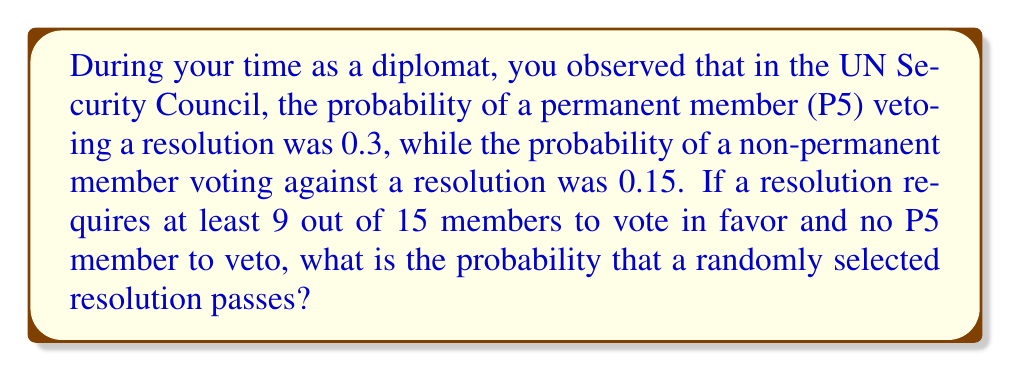Show me your answer to this math problem. Let's approach this step-by-step:

1) First, we need to calculate the probability that no P5 member vetoes the resolution:
   $P(\text{no veto}) = (1-0.3)^5 = 0.7^5 \approx 0.16807$

2) Now, we need to calculate the probability of at least 9 out of 15 members voting in favor. This is equivalent to the probability of 0 to 6 members voting against.

3) We can use the binomial probability formula:
   $P(X=k) = \binom{n}{k} p^k (1-p)^{n-k}$
   where $n=15$, $p=0.15$, and $k=0$ to $6$

4) Let's calculate this for each $k$ from 0 to 6:
   $P(X=0) = \binom{15}{0} 0.15^0 0.85^{15} \approx 0.0874$
   $P(X=1) = \binom{15}{1} 0.15^1 0.85^{14} \approx 0.2312$
   $P(X=2) = \binom{15}{2} 0.15^2 0.85^{13} \approx 0.2856$
   $P(X=3) = \binom{15}{3} 0.15^3 0.85^{12} \approx 0.2184$
   $P(X=4) = \binom{15}{4} 0.15^4 0.85^{11} \approx 0.1155$
   $P(X=5) = \binom{15}{5} 0.15^5 0.85^{10} \approx 0.0449$
   $P(X=6) = \binom{15}{6} 0.15^6 0.85^9 \approx 0.0132$

5) The sum of these probabilities is approximately 0.9962

6) The probability of both events occurring (no veto AND at least 9 in favor) is the product of their individual probabilities:

   $0.16807 * 0.9962 \approx 0.1674$
Answer: $0.1674$ or $16.74\%$ 